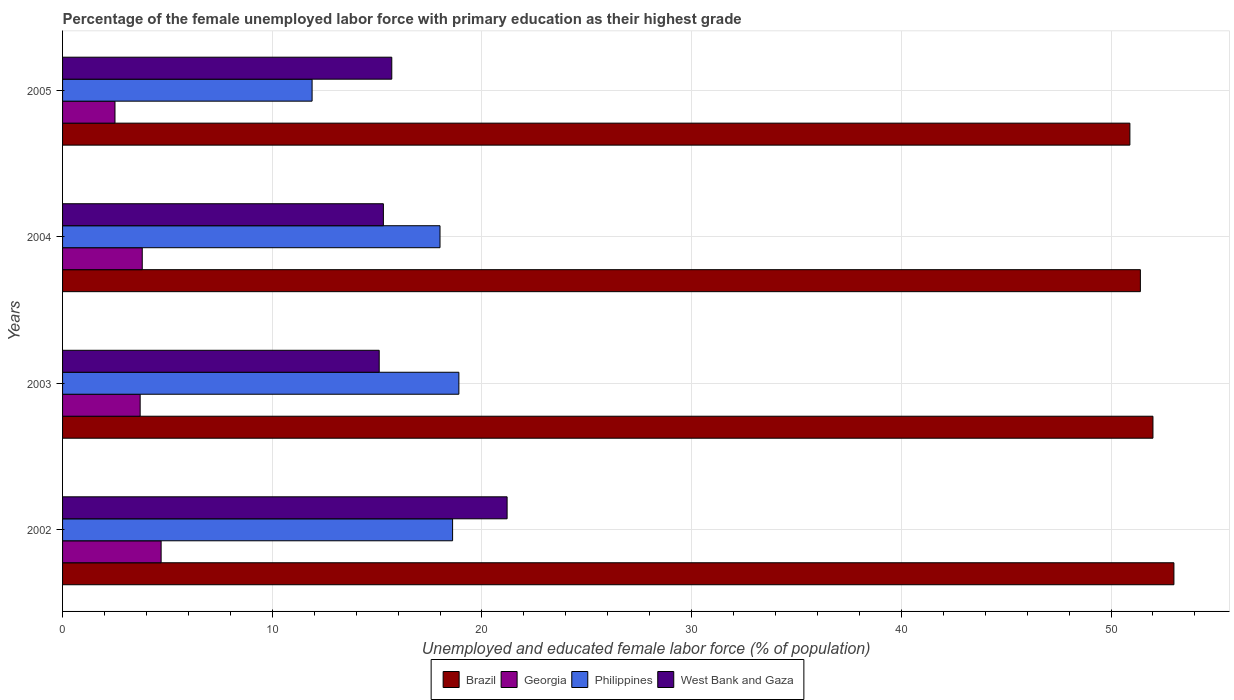How many different coloured bars are there?
Keep it short and to the point. 4. How many bars are there on the 3rd tick from the top?
Your response must be concise. 4. What is the percentage of the unemployed female labor force with primary education in Philippines in 2003?
Offer a terse response. 18.9. Across all years, what is the maximum percentage of the unemployed female labor force with primary education in Georgia?
Provide a succinct answer. 4.7. Across all years, what is the minimum percentage of the unemployed female labor force with primary education in West Bank and Gaza?
Make the answer very short. 15.1. What is the total percentage of the unemployed female labor force with primary education in Georgia in the graph?
Keep it short and to the point. 14.7. What is the difference between the percentage of the unemployed female labor force with primary education in Brazil in 2002 and that in 2003?
Ensure brevity in your answer.  1. What is the difference between the percentage of the unemployed female labor force with primary education in West Bank and Gaza in 2005 and the percentage of the unemployed female labor force with primary education in Brazil in 2003?
Offer a very short reply. -36.3. What is the average percentage of the unemployed female labor force with primary education in Philippines per year?
Your answer should be compact. 16.85. In the year 2004, what is the difference between the percentage of the unemployed female labor force with primary education in Georgia and percentage of the unemployed female labor force with primary education in Philippines?
Keep it short and to the point. -14.2. In how many years, is the percentage of the unemployed female labor force with primary education in West Bank and Gaza greater than 26 %?
Give a very brief answer. 0. What is the ratio of the percentage of the unemployed female labor force with primary education in West Bank and Gaza in 2002 to that in 2005?
Your answer should be compact. 1.35. What is the difference between the highest and the second highest percentage of the unemployed female labor force with primary education in West Bank and Gaza?
Your response must be concise. 5.5. What is the difference between the highest and the lowest percentage of the unemployed female labor force with primary education in West Bank and Gaza?
Keep it short and to the point. 6.1. Is the sum of the percentage of the unemployed female labor force with primary education in West Bank and Gaza in 2002 and 2004 greater than the maximum percentage of the unemployed female labor force with primary education in Philippines across all years?
Offer a very short reply. Yes. Is it the case that in every year, the sum of the percentage of the unemployed female labor force with primary education in Brazil and percentage of the unemployed female labor force with primary education in West Bank and Gaza is greater than the sum of percentage of the unemployed female labor force with primary education in Philippines and percentage of the unemployed female labor force with primary education in Georgia?
Your answer should be compact. Yes. What does the 4th bar from the top in 2004 represents?
Give a very brief answer. Brazil. What does the 4th bar from the bottom in 2002 represents?
Keep it short and to the point. West Bank and Gaza. Is it the case that in every year, the sum of the percentage of the unemployed female labor force with primary education in Brazil and percentage of the unemployed female labor force with primary education in Philippines is greater than the percentage of the unemployed female labor force with primary education in Georgia?
Give a very brief answer. Yes. How many bars are there?
Your answer should be compact. 16. Are all the bars in the graph horizontal?
Give a very brief answer. Yes. What is the difference between two consecutive major ticks on the X-axis?
Make the answer very short. 10. Are the values on the major ticks of X-axis written in scientific E-notation?
Provide a short and direct response. No. Does the graph contain any zero values?
Offer a very short reply. No. How are the legend labels stacked?
Offer a very short reply. Horizontal. What is the title of the graph?
Ensure brevity in your answer.  Percentage of the female unemployed labor force with primary education as their highest grade. What is the label or title of the X-axis?
Your answer should be compact. Unemployed and educated female labor force (% of population). What is the Unemployed and educated female labor force (% of population) in Georgia in 2002?
Make the answer very short. 4.7. What is the Unemployed and educated female labor force (% of population) of Philippines in 2002?
Make the answer very short. 18.6. What is the Unemployed and educated female labor force (% of population) in West Bank and Gaza in 2002?
Your answer should be very brief. 21.2. What is the Unemployed and educated female labor force (% of population) of Brazil in 2003?
Provide a succinct answer. 52. What is the Unemployed and educated female labor force (% of population) in Georgia in 2003?
Offer a very short reply. 3.7. What is the Unemployed and educated female labor force (% of population) of Philippines in 2003?
Your response must be concise. 18.9. What is the Unemployed and educated female labor force (% of population) of West Bank and Gaza in 2003?
Give a very brief answer. 15.1. What is the Unemployed and educated female labor force (% of population) of Brazil in 2004?
Offer a terse response. 51.4. What is the Unemployed and educated female labor force (% of population) of Georgia in 2004?
Offer a terse response. 3.8. What is the Unemployed and educated female labor force (% of population) of West Bank and Gaza in 2004?
Your answer should be very brief. 15.3. What is the Unemployed and educated female labor force (% of population) of Brazil in 2005?
Provide a short and direct response. 50.9. What is the Unemployed and educated female labor force (% of population) in Georgia in 2005?
Ensure brevity in your answer.  2.5. What is the Unemployed and educated female labor force (% of population) in Philippines in 2005?
Give a very brief answer. 11.9. What is the Unemployed and educated female labor force (% of population) of West Bank and Gaza in 2005?
Provide a succinct answer. 15.7. Across all years, what is the maximum Unemployed and educated female labor force (% of population) in Georgia?
Your response must be concise. 4.7. Across all years, what is the maximum Unemployed and educated female labor force (% of population) of Philippines?
Ensure brevity in your answer.  18.9. Across all years, what is the maximum Unemployed and educated female labor force (% of population) in West Bank and Gaza?
Give a very brief answer. 21.2. Across all years, what is the minimum Unemployed and educated female labor force (% of population) in Brazil?
Offer a very short reply. 50.9. Across all years, what is the minimum Unemployed and educated female labor force (% of population) of Georgia?
Give a very brief answer. 2.5. Across all years, what is the minimum Unemployed and educated female labor force (% of population) of Philippines?
Give a very brief answer. 11.9. Across all years, what is the minimum Unemployed and educated female labor force (% of population) in West Bank and Gaza?
Your answer should be very brief. 15.1. What is the total Unemployed and educated female labor force (% of population) in Brazil in the graph?
Provide a succinct answer. 207.3. What is the total Unemployed and educated female labor force (% of population) of Philippines in the graph?
Provide a succinct answer. 67.4. What is the total Unemployed and educated female labor force (% of population) in West Bank and Gaza in the graph?
Ensure brevity in your answer.  67.3. What is the difference between the Unemployed and educated female labor force (% of population) in Philippines in 2002 and that in 2003?
Ensure brevity in your answer.  -0.3. What is the difference between the Unemployed and educated female labor force (% of population) in Georgia in 2002 and that in 2004?
Give a very brief answer. 0.9. What is the difference between the Unemployed and educated female labor force (% of population) in Philippines in 2002 and that in 2004?
Give a very brief answer. 0.6. What is the difference between the Unemployed and educated female labor force (% of population) in Brazil in 2002 and that in 2005?
Your answer should be very brief. 2.1. What is the difference between the Unemployed and educated female labor force (% of population) of West Bank and Gaza in 2002 and that in 2005?
Offer a very short reply. 5.5. What is the difference between the Unemployed and educated female labor force (% of population) in Brazil in 2003 and that in 2004?
Provide a succinct answer. 0.6. What is the difference between the Unemployed and educated female labor force (% of population) of Georgia in 2003 and that in 2004?
Keep it short and to the point. -0.1. What is the difference between the Unemployed and educated female labor force (% of population) of Philippines in 2003 and that in 2004?
Make the answer very short. 0.9. What is the difference between the Unemployed and educated female labor force (% of population) of Brazil in 2003 and that in 2005?
Offer a very short reply. 1.1. What is the difference between the Unemployed and educated female labor force (% of population) of Philippines in 2003 and that in 2005?
Provide a short and direct response. 7. What is the difference between the Unemployed and educated female labor force (% of population) of West Bank and Gaza in 2003 and that in 2005?
Your response must be concise. -0.6. What is the difference between the Unemployed and educated female labor force (% of population) of Brazil in 2004 and that in 2005?
Your response must be concise. 0.5. What is the difference between the Unemployed and educated female labor force (% of population) of Brazil in 2002 and the Unemployed and educated female labor force (% of population) of Georgia in 2003?
Your answer should be compact. 49.3. What is the difference between the Unemployed and educated female labor force (% of population) in Brazil in 2002 and the Unemployed and educated female labor force (% of population) in Philippines in 2003?
Provide a succinct answer. 34.1. What is the difference between the Unemployed and educated female labor force (% of population) in Brazil in 2002 and the Unemployed and educated female labor force (% of population) in West Bank and Gaza in 2003?
Make the answer very short. 37.9. What is the difference between the Unemployed and educated female labor force (% of population) in Georgia in 2002 and the Unemployed and educated female labor force (% of population) in Philippines in 2003?
Ensure brevity in your answer.  -14.2. What is the difference between the Unemployed and educated female labor force (% of population) of Georgia in 2002 and the Unemployed and educated female labor force (% of population) of West Bank and Gaza in 2003?
Your answer should be very brief. -10.4. What is the difference between the Unemployed and educated female labor force (% of population) in Brazil in 2002 and the Unemployed and educated female labor force (% of population) in Georgia in 2004?
Provide a succinct answer. 49.2. What is the difference between the Unemployed and educated female labor force (% of population) of Brazil in 2002 and the Unemployed and educated female labor force (% of population) of Philippines in 2004?
Provide a short and direct response. 35. What is the difference between the Unemployed and educated female labor force (% of population) of Brazil in 2002 and the Unemployed and educated female labor force (% of population) of West Bank and Gaza in 2004?
Give a very brief answer. 37.7. What is the difference between the Unemployed and educated female labor force (% of population) in Brazil in 2002 and the Unemployed and educated female labor force (% of population) in Georgia in 2005?
Your answer should be compact. 50.5. What is the difference between the Unemployed and educated female labor force (% of population) in Brazil in 2002 and the Unemployed and educated female labor force (% of population) in Philippines in 2005?
Make the answer very short. 41.1. What is the difference between the Unemployed and educated female labor force (% of population) in Brazil in 2002 and the Unemployed and educated female labor force (% of population) in West Bank and Gaza in 2005?
Your response must be concise. 37.3. What is the difference between the Unemployed and educated female labor force (% of population) in Georgia in 2002 and the Unemployed and educated female labor force (% of population) in West Bank and Gaza in 2005?
Ensure brevity in your answer.  -11. What is the difference between the Unemployed and educated female labor force (% of population) in Philippines in 2002 and the Unemployed and educated female labor force (% of population) in West Bank and Gaza in 2005?
Your response must be concise. 2.9. What is the difference between the Unemployed and educated female labor force (% of population) of Brazil in 2003 and the Unemployed and educated female labor force (% of population) of Georgia in 2004?
Keep it short and to the point. 48.2. What is the difference between the Unemployed and educated female labor force (% of population) of Brazil in 2003 and the Unemployed and educated female labor force (% of population) of West Bank and Gaza in 2004?
Make the answer very short. 36.7. What is the difference between the Unemployed and educated female labor force (% of population) of Georgia in 2003 and the Unemployed and educated female labor force (% of population) of Philippines in 2004?
Keep it short and to the point. -14.3. What is the difference between the Unemployed and educated female labor force (% of population) in Philippines in 2003 and the Unemployed and educated female labor force (% of population) in West Bank and Gaza in 2004?
Keep it short and to the point. 3.6. What is the difference between the Unemployed and educated female labor force (% of population) in Brazil in 2003 and the Unemployed and educated female labor force (% of population) in Georgia in 2005?
Provide a succinct answer. 49.5. What is the difference between the Unemployed and educated female labor force (% of population) of Brazil in 2003 and the Unemployed and educated female labor force (% of population) of Philippines in 2005?
Ensure brevity in your answer.  40.1. What is the difference between the Unemployed and educated female labor force (% of population) in Brazil in 2003 and the Unemployed and educated female labor force (% of population) in West Bank and Gaza in 2005?
Offer a very short reply. 36.3. What is the difference between the Unemployed and educated female labor force (% of population) in Georgia in 2003 and the Unemployed and educated female labor force (% of population) in Philippines in 2005?
Your answer should be compact. -8.2. What is the difference between the Unemployed and educated female labor force (% of population) in Brazil in 2004 and the Unemployed and educated female labor force (% of population) in Georgia in 2005?
Provide a succinct answer. 48.9. What is the difference between the Unemployed and educated female labor force (% of population) in Brazil in 2004 and the Unemployed and educated female labor force (% of population) in Philippines in 2005?
Keep it short and to the point. 39.5. What is the difference between the Unemployed and educated female labor force (% of population) in Brazil in 2004 and the Unemployed and educated female labor force (% of population) in West Bank and Gaza in 2005?
Your response must be concise. 35.7. What is the average Unemployed and educated female labor force (% of population) in Brazil per year?
Your answer should be compact. 51.83. What is the average Unemployed and educated female labor force (% of population) of Georgia per year?
Provide a succinct answer. 3.67. What is the average Unemployed and educated female labor force (% of population) of Philippines per year?
Your response must be concise. 16.85. What is the average Unemployed and educated female labor force (% of population) in West Bank and Gaza per year?
Your response must be concise. 16.82. In the year 2002, what is the difference between the Unemployed and educated female labor force (% of population) of Brazil and Unemployed and educated female labor force (% of population) of Georgia?
Provide a succinct answer. 48.3. In the year 2002, what is the difference between the Unemployed and educated female labor force (% of population) of Brazil and Unemployed and educated female labor force (% of population) of Philippines?
Your response must be concise. 34.4. In the year 2002, what is the difference between the Unemployed and educated female labor force (% of population) of Brazil and Unemployed and educated female labor force (% of population) of West Bank and Gaza?
Offer a very short reply. 31.8. In the year 2002, what is the difference between the Unemployed and educated female labor force (% of population) of Georgia and Unemployed and educated female labor force (% of population) of Philippines?
Your answer should be compact. -13.9. In the year 2002, what is the difference between the Unemployed and educated female labor force (% of population) in Georgia and Unemployed and educated female labor force (% of population) in West Bank and Gaza?
Your response must be concise. -16.5. In the year 2003, what is the difference between the Unemployed and educated female labor force (% of population) of Brazil and Unemployed and educated female labor force (% of population) of Georgia?
Offer a terse response. 48.3. In the year 2003, what is the difference between the Unemployed and educated female labor force (% of population) in Brazil and Unemployed and educated female labor force (% of population) in Philippines?
Offer a very short reply. 33.1. In the year 2003, what is the difference between the Unemployed and educated female labor force (% of population) in Brazil and Unemployed and educated female labor force (% of population) in West Bank and Gaza?
Keep it short and to the point. 36.9. In the year 2003, what is the difference between the Unemployed and educated female labor force (% of population) of Georgia and Unemployed and educated female labor force (% of population) of Philippines?
Offer a very short reply. -15.2. In the year 2004, what is the difference between the Unemployed and educated female labor force (% of population) in Brazil and Unemployed and educated female labor force (% of population) in Georgia?
Give a very brief answer. 47.6. In the year 2004, what is the difference between the Unemployed and educated female labor force (% of population) of Brazil and Unemployed and educated female labor force (% of population) of Philippines?
Provide a succinct answer. 33.4. In the year 2004, what is the difference between the Unemployed and educated female labor force (% of population) in Brazil and Unemployed and educated female labor force (% of population) in West Bank and Gaza?
Offer a very short reply. 36.1. In the year 2004, what is the difference between the Unemployed and educated female labor force (% of population) in Philippines and Unemployed and educated female labor force (% of population) in West Bank and Gaza?
Offer a terse response. 2.7. In the year 2005, what is the difference between the Unemployed and educated female labor force (% of population) of Brazil and Unemployed and educated female labor force (% of population) of Georgia?
Ensure brevity in your answer.  48.4. In the year 2005, what is the difference between the Unemployed and educated female labor force (% of population) in Brazil and Unemployed and educated female labor force (% of population) in West Bank and Gaza?
Give a very brief answer. 35.2. In the year 2005, what is the difference between the Unemployed and educated female labor force (% of population) in Georgia and Unemployed and educated female labor force (% of population) in West Bank and Gaza?
Offer a very short reply. -13.2. What is the ratio of the Unemployed and educated female labor force (% of population) of Brazil in 2002 to that in 2003?
Provide a succinct answer. 1.02. What is the ratio of the Unemployed and educated female labor force (% of population) of Georgia in 2002 to that in 2003?
Provide a succinct answer. 1.27. What is the ratio of the Unemployed and educated female labor force (% of population) of Philippines in 2002 to that in 2003?
Provide a succinct answer. 0.98. What is the ratio of the Unemployed and educated female labor force (% of population) in West Bank and Gaza in 2002 to that in 2003?
Your response must be concise. 1.4. What is the ratio of the Unemployed and educated female labor force (% of population) in Brazil in 2002 to that in 2004?
Offer a terse response. 1.03. What is the ratio of the Unemployed and educated female labor force (% of population) of Georgia in 2002 to that in 2004?
Make the answer very short. 1.24. What is the ratio of the Unemployed and educated female labor force (% of population) in Philippines in 2002 to that in 2004?
Your response must be concise. 1.03. What is the ratio of the Unemployed and educated female labor force (% of population) in West Bank and Gaza in 2002 to that in 2004?
Give a very brief answer. 1.39. What is the ratio of the Unemployed and educated female labor force (% of population) in Brazil in 2002 to that in 2005?
Your answer should be compact. 1.04. What is the ratio of the Unemployed and educated female labor force (% of population) in Georgia in 2002 to that in 2005?
Make the answer very short. 1.88. What is the ratio of the Unemployed and educated female labor force (% of population) of Philippines in 2002 to that in 2005?
Provide a short and direct response. 1.56. What is the ratio of the Unemployed and educated female labor force (% of population) in West Bank and Gaza in 2002 to that in 2005?
Your answer should be compact. 1.35. What is the ratio of the Unemployed and educated female labor force (% of population) in Brazil in 2003 to that in 2004?
Ensure brevity in your answer.  1.01. What is the ratio of the Unemployed and educated female labor force (% of population) in Georgia in 2003 to that in 2004?
Provide a short and direct response. 0.97. What is the ratio of the Unemployed and educated female labor force (% of population) in West Bank and Gaza in 2003 to that in 2004?
Your answer should be very brief. 0.99. What is the ratio of the Unemployed and educated female labor force (% of population) of Brazil in 2003 to that in 2005?
Give a very brief answer. 1.02. What is the ratio of the Unemployed and educated female labor force (% of population) of Georgia in 2003 to that in 2005?
Give a very brief answer. 1.48. What is the ratio of the Unemployed and educated female labor force (% of population) of Philippines in 2003 to that in 2005?
Give a very brief answer. 1.59. What is the ratio of the Unemployed and educated female labor force (% of population) in West Bank and Gaza in 2003 to that in 2005?
Offer a very short reply. 0.96. What is the ratio of the Unemployed and educated female labor force (% of population) of Brazil in 2004 to that in 2005?
Your answer should be very brief. 1.01. What is the ratio of the Unemployed and educated female labor force (% of population) of Georgia in 2004 to that in 2005?
Ensure brevity in your answer.  1.52. What is the ratio of the Unemployed and educated female labor force (% of population) in Philippines in 2004 to that in 2005?
Provide a short and direct response. 1.51. What is the ratio of the Unemployed and educated female labor force (% of population) in West Bank and Gaza in 2004 to that in 2005?
Your answer should be compact. 0.97. What is the difference between the highest and the second highest Unemployed and educated female labor force (% of population) in West Bank and Gaza?
Your answer should be compact. 5.5. What is the difference between the highest and the lowest Unemployed and educated female labor force (% of population) of Georgia?
Your answer should be compact. 2.2. What is the difference between the highest and the lowest Unemployed and educated female labor force (% of population) in Philippines?
Keep it short and to the point. 7. What is the difference between the highest and the lowest Unemployed and educated female labor force (% of population) in West Bank and Gaza?
Ensure brevity in your answer.  6.1. 